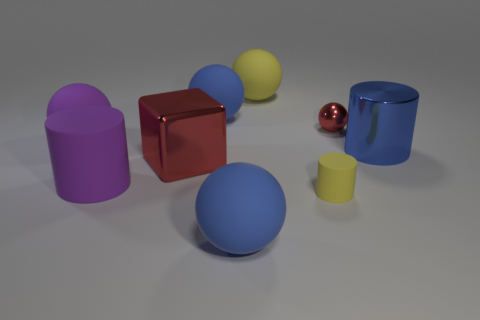How many blue spheres must be subtracted to get 1 blue spheres? 1 Subtract all purple spheres. How many spheres are left? 4 Subtract all tiny balls. How many balls are left? 4 Add 1 large yellow rubber spheres. How many objects exist? 10 Subtract all yellow balls. Subtract all brown cylinders. How many balls are left? 4 Subtract all blocks. How many objects are left? 8 Add 9 small cyan metal objects. How many small cyan metal objects exist? 9 Subtract 1 yellow balls. How many objects are left? 8 Subtract all green things. Subtract all shiny balls. How many objects are left? 8 Add 1 red metal things. How many red metal things are left? 3 